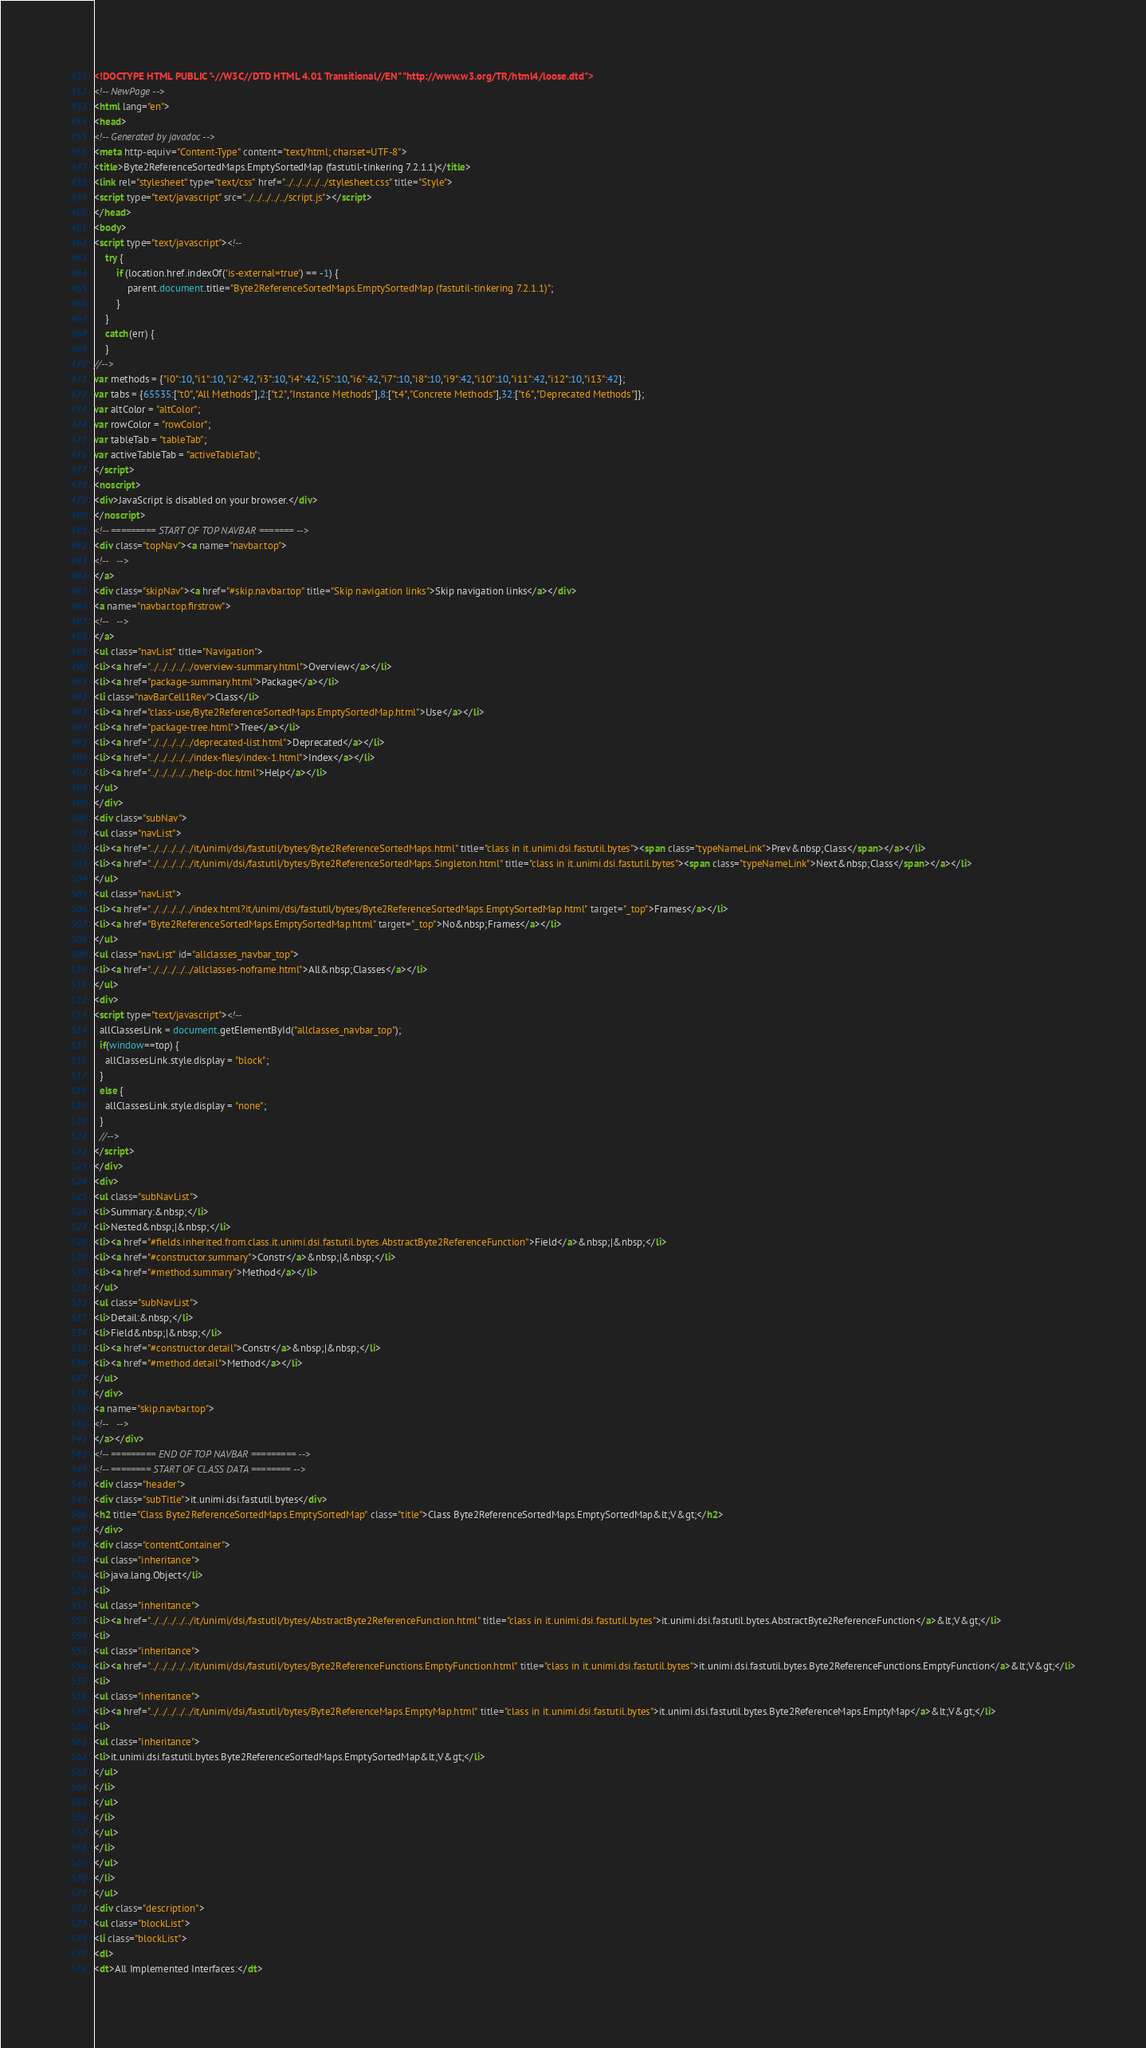Convert code to text. <code><loc_0><loc_0><loc_500><loc_500><_HTML_><!DOCTYPE HTML PUBLIC "-//W3C//DTD HTML 4.01 Transitional//EN" "http://www.w3.org/TR/html4/loose.dtd">
<!-- NewPage -->
<html lang="en">
<head>
<!-- Generated by javadoc -->
<meta http-equiv="Content-Type" content="text/html; charset=UTF-8">
<title>Byte2ReferenceSortedMaps.EmptySortedMap (fastutil-tinkering 7.2.1.1)</title>
<link rel="stylesheet" type="text/css" href="../../../../../stylesheet.css" title="Style">
<script type="text/javascript" src="../../../../../script.js"></script>
</head>
<body>
<script type="text/javascript"><!--
    try {
        if (location.href.indexOf('is-external=true') == -1) {
            parent.document.title="Byte2ReferenceSortedMaps.EmptySortedMap (fastutil-tinkering 7.2.1.1)";
        }
    }
    catch(err) {
    }
//-->
var methods = {"i0":10,"i1":10,"i2":42,"i3":10,"i4":42,"i5":10,"i6":42,"i7":10,"i8":10,"i9":42,"i10":10,"i11":42,"i12":10,"i13":42};
var tabs = {65535:["t0","All Methods"],2:["t2","Instance Methods"],8:["t4","Concrete Methods"],32:["t6","Deprecated Methods"]};
var altColor = "altColor";
var rowColor = "rowColor";
var tableTab = "tableTab";
var activeTableTab = "activeTableTab";
</script>
<noscript>
<div>JavaScript is disabled on your browser.</div>
</noscript>
<!-- ========= START OF TOP NAVBAR ======= -->
<div class="topNav"><a name="navbar.top">
<!--   -->
</a>
<div class="skipNav"><a href="#skip.navbar.top" title="Skip navigation links">Skip navigation links</a></div>
<a name="navbar.top.firstrow">
<!--   -->
</a>
<ul class="navList" title="Navigation">
<li><a href="../../../../../overview-summary.html">Overview</a></li>
<li><a href="package-summary.html">Package</a></li>
<li class="navBarCell1Rev">Class</li>
<li><a href="class-use/Byte2ReferenceSortedMaps.EmptySortedMap.html">Use</a></li>
<li><a href="package-tree.html">Tree</a></li>
<li><a href="../../../../../deprecated-list.html">Deprecated</a></li>
<li><a href="../../../../../index-files/index-1.html">Index</a></li>
<li><a href="../../../../../help-doc.html">Help</a></li>
</ul>
</div>
<div class="subNav">
<ul class="navList">
<li><a href="../../../../../it/unimi/dsi/fastutil/bytes/Byte2ReferenceSortedMaps.html" title="class in it.unimi.dsi.fastutil.bytes"><span class="typeNameLink">Prev&nbsp;Class</span></a></li>
<li><a href="../../../../../it/unimi/dsi/fastutil/bytes/Byte2ReferenceSortedMaps.Singleton.html" title="class in it.unimi.dsi.fastutil.bytes"><span class="typeNameLink">Next&nbsp;Class</span></a></li>
</ul>
<ul class="navList">
<li><a href="../../../../../index.html?it/unimi/dsi/fastutil/bytes/Byte2ReferenceSortedMaps.EmptySortedMap.html" target="_top">Frames</a></li>
<li><a href="Byte2ReferenceSortedMaps.EmptySortedMap.html" target="_top">No&nbsp;Frames</a></li>
</ul>
<ul class="navList" id="allclasses_navbar_top">
<li><a href="../../../../../allclasses-noframe.html">All&nbsp;Classes</a></li>
</ul>
<div>
<script type="text/javascript"><!--
  allClassesLink = document.getElementById("allclasses_navbar_top");
  if(window==top) {
    allClassesLink.style.display = "block";
  }
  else {
    allClassesLink.style.display = "none";
  }
  //-->
</script>
</div>
<div>
<ul class="subNavList">
<li>Summary:&nbsp;</li>
<li>Nested&nbsp;|&nbsp;</li>
<li><a href="#fields.inherited.from.class.it.unimi.dsi.fastutil.bytes.AbstractByte2ReferenceFunction">Field</a>&nbsp;|&nbsp;</li>
<li><a href="#constructor.summary">Constr</a>&nbsp;|&nbsp;</li>
<li><a href="#method.summary">Method</a></li>
</ul>
<ul class="subNavList">
<li>Detail:&nbsp;</li>
<li>Field&nbsp;|&nbsp;</li>
<li><a href="#constructor.detail">Constr</a>&nbsp;|&nbsp;</li>
<li><a href="#method.detail">Method</a></li>
</ul>
</div>
<a name="skip.navbar.top">
<!--   -->
</a></div>
<!-- ========= END OF TOP NAVBAR ========= -->
<!-- ======== START OF CLASS DATA ======== -->
<div class="header">
<div class="subTitle">it.unimi.dsi.fastutil.bytes</div>
<h2 title="Class Byte2ReferenceSortedMaps.EmptySortedMap" class="title">Class Byte2ReferenceSortedMaps.EmptySortedMap&lt;V&gt;</h2>
</div>
<div class="contentContainer">
<ul class="inheritance">
<li>java.lang.Object</li>
<li>
<ul class="inheritance">
<li><a href="../../../../../it/unimi/dsi/fastutil/bytes/AbstractByte2ReferenceFunction.html" title="class in it.unimi.dsi.fastutil.bytes">it.unimi.dsi.fastutil.bytes.AbstractByte2ReferenceFunction</a>&lt;V&gt;</li>
<li>
<ul class="inheritance">
<li><a href="../../../../../it/unimi/dsi/fastutil/bytes/Byte2ReferenceFunctions.EmptyFunction.html" title="class in it.unimi.dsi.fastutil.bytes">it.unimi.dsi.fastutil.bytes.Byte2ReferenceFunctions.EmptyFunction</a>&lt;V&gt;</li>
<li>
<ul class="inheritance">
<li><a href="../../../../../it/unimi/dsi/fastutil/bytes/Byte2ReferenceMaps.EmptyMap.html" title="class in it.unimi.dsi.fastutil.bytes">it.unimi.dsi.fastutil.bytes.Byte2ReferenceMaps.EmptyMap</a>&lt;V&gt;</li>
<li>
<ul class="inheritance">
<li>it.unimi.dsi.fastutil.bytes.Byte2ReferenceSortedMaps.EmptySortedMap&lt;V&gt;</li>
</ul>
</li>
</ul>
</li>
</ul>
</li>
</ul>
</li>
</ul>
<div class="description">
<ul class="blockList">
<li class="blockList">
<dl>
<dt>All Implemented Interfaces:</dt></code> 